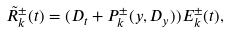Convert formula to latex. <formula><loc_0><loc_0><loc_500><loc_500>\tilde { R } _ { k } ^ { \pm } ( t ) = ( D _ { t } + P _ { k } ^ { \pm } ( y , D _ { y } ) ) E _ { k } ^ { \pm } ( t ) ,</formula> 